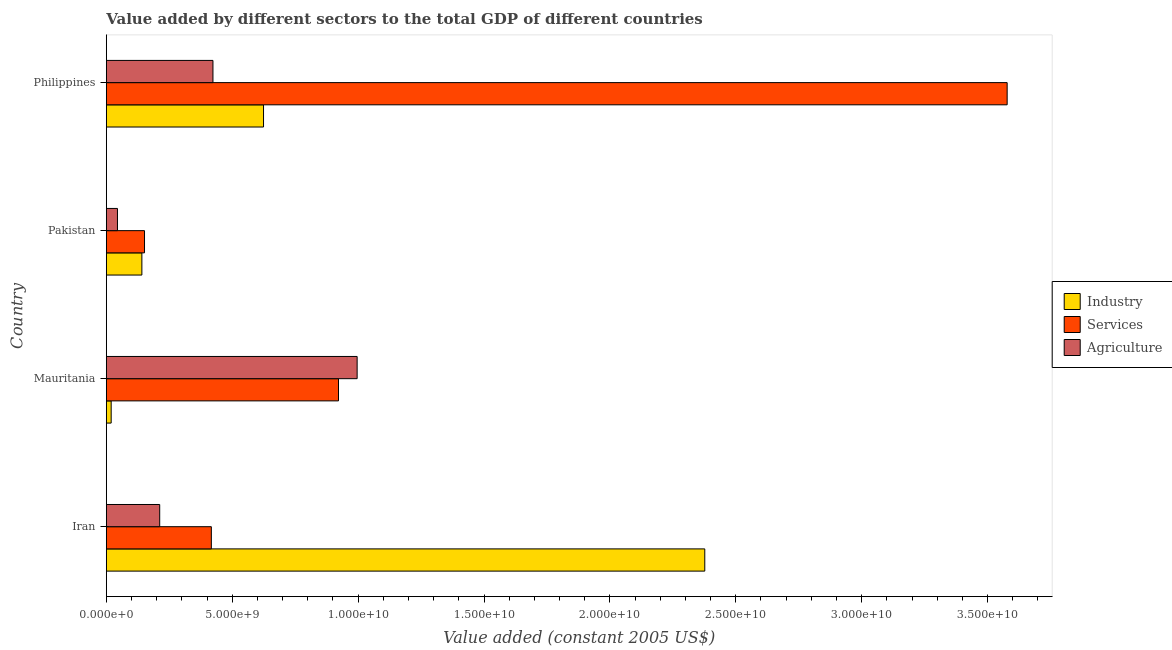How many bars are there on the 1st tick from the top?
Your answer should be compact. 3. How many bars are there on the 4th tick from the bottom?
Your response must be concise. 3. What is the value added by industrial sector in Pakistan?
Provide a short and direct response. 1.41e+09. Across all countries, what is the maximum value added by agricultural sector?
Offer a very short reply. 9.96e+09. Across all countries, what is the minimum value added by industrial sector?
Ensure brevity in your answer.  1.92e+08. In which country was the value added by agricultural sector maximum?
Offer a terse response. Mauritania. In which country was the value added by industrial sector minimum?
Offer a terse response. Mauritania. What is the total value added by services in the graph?
Offer a terse response. 5.07e+1. What is the difference between the value added by industrial sector in Mauritania and that in Pakistan?
Offer a very short reply. -1.22e+09. What is the difference between the value added by industrial sector in Philippines and the value added by agricultural sector in Pakistan?
Give a very brief answer. 5.80e+09. What is the average value added by services per country?
Offer a terse response. 1.27e+1. What is the difference between the value added by services and value added by agricultural sector in Philippines?
Your answer should be compact. 3.15e+1. In how many countries, is the value added by services greater than 25000000000 US$?
Your answer should be very brief. 1. What is the ratio of the value added by services in Pakistan to that in Philippines?
Your answer should be very brief. 0.04. Is the value added by agricultural sector in Mauritania less than that in Philippines?
Give a very brief answer. No. What is the difference between the highest and the second highest value added by agricultural sector?
Offer a terse response. 5.73e+09. What is the difference between the highest and the lowest value added by agricultural sector?
Make the answer very short. 9.52e+09. In how many countries, is the value added by services greater than the average value added by services taken over all countries?
Give a very brief answer. 1. What does the 1st bar from the top in Philippines represents?
Provide a succinct answer. Agriculture. What does the 2nd bar from the bottom in Mauritania represents?
Give a very brief answer. Services. Is it the case that in every country, the sum of the value added by industrial sector and value added by services is greater than the value added by agricultural sector?
Provide a succinct answer. No. How many bars are there?
Keep it short and to the point. 12. Are all the bars in the graph horizontal?
Keep it short and to the point. Yes. What is the difference between two consecutive major ticks on the X-axis?
Your answer should be compact. 5.00e+09. Where does the legend appear in the graph?
Make the answer very short. Center right. What is the title of the graph?
Give a very brief answer. Value added by different sectors to the total GDP of different countries. Does "Transport" appear as one of the legend labels in the graph?
Give a very brief answer. No. What is the label or title of the X-axis?
Make the answer very short. Value added (constant 2005 US$). What is the label or title of the Y-axis?
Offer a very short reply. Country. What is the Value added (constant 2005 US$) of Industry in Iran?
Provide a succinct answer. 2.38e+1. What is the Value added (constant 2005 US$) of Services in Iran?
Ensure brevity in your answer.  4.17e+09. What is the Value added (constant 2005 US$) in Agriculture in Iran?
Your answer should be compact. 2.12e+09. What is the Value added (constant 2005 US$) in Industry in Mauritania?
Offer a terse response. 1.92e+08. What is the Value added (constant 2005 US$) in Services in Mauritania?
Make the answer very short. 9.22e+09. What is the Value added (constant 2005 US$) in Agriculture in Mauritania?
Provide a succinct answer. 9.96e+09. What is the Value added (constant 2005 US$) of Industry in Pakistan?
Keep it short and to the point. 1.41e+09. What is the Value added (constant 2005 US$) of Services in Pakistan?
Offer a very short reply. 1.52e+09. What is the Value added (constant 2005 US$) in Agriculture in Pakistan?
Your answer should be compact. 4.42e+08. What is the Value added (constant 2005 US$) in Industry in Philippines?
Provide a short and direct response. 6.24e+09. What is the Value added (constant 2005 US$) of Services in Philippines?
Keep it short and to the point. 3.58e+1. What is the Value added (constant 2005 US$) of Agriculture in Philippines?
Keep it short and to the point. 4.23e+09. Across all countries, what is the maximum Value added (constant 2005 US$) in Industry?
Provide a succinct answer. 2.38e+1. Across all countries, what is the maximum Value added (constant 2005 US$) in Services?
Give a very brief answer. 3.58e+1. Across all countries, what is the maximum Value added (constant 2005 US$) in Agriculture?
Make the answer very short. 9.96e+09. Across all countries, what is the minimum Value added (constant 2005 US$) of Industry?
Your answer should be very brief. 1.92e+08. Across all countries, what is the minimum Value added (constant 2005 US$) in Services?
Offer a very short reply. 1.52e+09. Across all countries, what is the minimum Value added (constant 2005 US$) of Agriculture?
Provide a succinct answer. 4.42e+08. What is the total Value added (constant 2005 US$) of Industry in the graph?
Keep it short and to the point. 3.16e+1. What is the total Value added (constant 2005 US$) in Services in the graph?
Offer a terse response. 5.07e+1. What is the total Value added (constant 2005 US$) in Agriculture in the graph?
Ensure brevity in your answer.  1.68e+1. What is the difference between the Value added (constant 2005 US$) of Industry in Iran and that in Mauritania?
Provide a succinct answer. 2.36e+1. What is the difference between the Value added (constant 2005 US$) in Services in Iran and that in Mauritania?
Your answer should be very brief. -5.05e+09. What is the difference between the Value added (constant 2005 US$) of Agriculture in Iran and that in Mauritania?
Keep it short and to the point. -7.84e+09. What is the difference between the Value added (constant 2005 US$) in Industry in Iran and that in Pakistan?
Make the answer very short. 2.24e+1. What is the difference between the Value added (constant 2005 US$) in Services in Iran and that in Pakistan?
Offer a very short reply. 2.65e+09. What is the difference between the Value added (constant 2005 US$) of Agriculture in Iran and that in Pakistan?
Ensure brevity in your answer.  1.68e+09. What is the difference between the Value added (constant 2005 US$) of Industry in Iran and that in Philippines?
Provide a short and direct response. 1.75e+1. What is the difference between the Value added (constant 2005 US$) in Services in Iran and that in Philippines?
Offer a terse response. -3.16e+1. What is the difference between the Value added (constant 2005 US$) of Agriculture in Iran and that in Philippines?
Ensure brevity in your answer.  -2.11e+09. What is the difference between the Value added (constant 2005 US$) in Industry in Mauritania and that in Pakistan?
Offer a terse response. -1.22e+09. What is the difference between the Value added (constant 2005 US$) of Services in Mauritania and that in Pakistan?
Keep it short and to the point. 7.70e+09. What is the difference between the Value added (constant 2005 US$) in Agriculture in Mauritania and that in Pakistan?
Provide a succinct answer. 9.52e+09. What is the difference between the Value added (constant 2005 US$) in Industry in Mauritania and that in Philippines?
Offer a very short reply. -6.05e+09. What is the difference between the Value added (constant 2005 US$) in Services in Mauritania and that in Philippines?
Make the answer very short. -2.66e+1. What is the difference between the Value added (constant 2005 US$) of Agriculture in Mauritania and that in Philippines?
Give a very brief answer. 5.73e+09. What is the difference between the Value added (constant 2005 US$) of Industry in Pakistan and that in Philippines?
Give a very brief answer. -4.83e+09. What is the difference between the Value added (constant 2005 US$) of Services in Pakistan and that in Philippines?
Your response must be concise. -3.43e+1. What is the difference between the Value added (constant 2005 US$) in Agriculture in Pakistan and that in Philippines?
Your answer should be compact. -3.79e+09. What is the difference between the Value added (constant 2005 US$) of Industry in Iran and the Value added (constant 2005 US$) of Services in Mauritania?
Give a very brief answer. 1.45e+1. What is the difference between the Value added (constant 2005 US$) in Industry in Iran and the Value added (constant 2005 US$) in Agriculture in Mauritania?
Ensure brevity in your answer.  1.38e+1. What is the difference between the Value added (constant 2005 US$) of Services in Iran and the Value added (constant 2005 US$) of Agriculture in Mauritania?
Your answer should be very brief. -5.79e+09. What is the difference between the Value added (constant 2005 US$) in Industry in Iran and the Value added (constant 2005 US$) in Services in Pakistan?
Your answer should be very brief. 2.23e+1. What is the difference between the Value added (constant 2005 US$) in Industry in Iran and the Value added (constant 2005 US$) in Agriculture in Pakistan?
Ensure brevity in your answer.  2.33e+1. What is the difference between the Value added (constant 2005 US$) in Services in Iran and the Value added (constant 2005 US$) in Agriculture in Pakistan?
Give a very brief answer. 3.73e+09. What is the difference between the Value added (constant 2005 US$) of Industry in Iran and the Value added (constant 2005 US$) of Services in Philippines?
Keep it short and to the point. -1.20e+1. What is the difference between the Value added (constant 2005 US$) of Industry in Iran and the Value added (constant 2005 US$) of Agriculture in Philippines?
Give a very brief answer. 1.95e+1. What is the difference between the Value added (constant 2005 US$) in Services in Iran and the Value added (constant 2005 US$) in Agriculture in Philippines?
Offer a terse response. -6.35e+07. What is the difference between the Value added (constant 2005 US$) in Industry in Mauritania and the Value added (constant 2005 US$) in Services in Pakistan?
Offer a terse response. -1.32e+09. What is the difference between the Value added (constant 2005 US$) of Industry in Mauritania and the Value added (constant 2005 US$) of Agriculture in Pakistan?
Your answer should be very brief. -2.50e+08. What is the difference between the Value added (constant 2005 US$) in Services in Mauritania and the Value added (constant 2005 US$) in Agriculture in Pakistan?
Your answer should be very brief. 8.78e+09. What is the difference between the Value added (constant 2005 US$) in Industry in Mauritania and the Value added (constant 2005 US$) in Services in Philippines?
Provide a succinct answer. -3.56e+1. What is the difference between the Value added (constant 2005 US$) in Industry in Mauritania and the Value added (constant 2005 US$) in Agriculture in Philippines?
Give a very brief answer. -4.04e+09. What is the difference between the Value added (constant 2005 US$) of Services in Mauritania and the Value added (constant 2005 US$) of Agriculture in Philippines?
Give a very brief answer. 4.99e+09. What is the difference between the Value added (constant 2005 US$) in Industry in Pakistan and the Value added (constant 2005 US$) in Services in Philippines?
Offer a very short reply. -3.44e+1. What is the difference between the Value added (constant 2005 US$) in Industry in Pakistan and the Value added (constant 2005 US$) in Agriculture in Philippines?
Provide a short and direct response. -2.82e+09. What is the difference between the Value added (constant 2005 US$) of Services in Pakistan and the Value added (constant 2005 US$) of Agriculture in Philippines?
Provide a succinct answer. -2.72e+09. What is the average Value added (constant 2005 US$) in Industry per country?
Keep it short and to the point. 7.90e+09. What is the average Value added (constant 2005 US$) in Services per country?
Make the answer very short. 1.27e+1. What is the average Value added (constant 2005 US$) in Agriculture per country?
Your answer should be very brief. 4.19e+09. What is the difference between the Value added (constant 2005 US$) of Industry and Value added (constant 2005 US$) of Services in Iran?
Keep it short and to the point. 1.96e+1. What is the difference between the Value added (constant 2005 US$) in Industry and Value added (constant 2005 US$) in Agriculture in Iran?
Your response must be concise. 2.16e+1. What is the difference between the Value added (constant 2005 US$) of Services and Value added (constant 2005 US$) of Agriculture in Iran?
Make the answer very short. 2.05e+09. What is the difference between the Value added (constant 2005 US$) of Industry and Value added (constant 2005 US$) of Services in Mauritania?
Make the answer very short. -9.03e+09. What is the difference between the Value added (constant 2005 US$) in Industry and Value added (constant 2005 US$) in Agriculture in Mauritania?
Keep it short and to the point. -9.77e+09. What is the difference between the Value added (constant 2005 US$) of Services and Value added (constant 2005 US$) of Agriculture in Mauritania?
Offer a terse response. -7.40e+08. What is the difference between the Value added (constant 2005 US$) in Industry and Value added (constant 2005 US$) in Services in Pakistan?
Make the answer very short. -1.05e+08. What is the difference between the Value added (constant 2005 US$) in Industry and Value added (constant 2005 US$) in Agriculture in Pakistan?
Your answer should be compact. 9.70e+08. What is the difference between the Value added (constant 2005 US$) in Services and Value added (constant 2005 US$) in Agriculture in Pakistan?
Offer a very short reply. 1.07e+09. What is the difference between the Value added (constant 2005 US$) in Industry and Value added (constant 2005 US$) in Services in Philippines?
Your response must be concise. -2.95e+1. What is the difference between the Value added (constant 2005 US$) of Industry and Value added (constant 2005 US$) of Agriculture in Philippines?
Your response must be concise. 2.01e+09. What is the difference between the Value added (constant 2005 US$) in Services and Value added (constant 2005 US$) in Agriculture in Philippines?
Provide a succinct answer. 3.15e+1. What is the ratio of the Value added (constant 2005 US$) in Industry in Iran to that in Mauritania?
Your answer should be compact. 123.7. What is the ratio of the Value added (constant 2005 US$) of Services in Iran to that in Mauritania?
Offer a very short reply. 0.45. What is the ratio of the Value added (constant 2005 US$) of Agriculture in Iran to that in Mauritania?
Offer a very short reply. 0.21. What is the ratio of the Value added (constant 2005 US$) of Industry in Iran to that in Pakistan?
Ensure brevity in your answer.  16.84. What is the ratio of the Value added (constant 2005 US$) of Services in Iran to that in Pakistan?
Offer a very short reply. 2.75. What is the ratio of the Value added (constant 2005 US$) in Agriculture in Iran to that in Pakistan?
Your response must be concise. 4.79. What is the ratio of the Value added (constant 2005 US$) in Industry in Iran to that in Philippines?
Your answer should be compact. 3.81. What is the ratio of the Value added (constant 2005 US$) of Services in Iran to that in Philippines?
Make the answer very short. 0.12. What is the ratio of the Value added (constant 2005 US$) of Agriculture in Iran to that in Philippines?
Provide a succinct answer. 0.5. What is the ratio of the Value added (constant 2005 US$) in Industry in Mauritania to that in Pakistan?
Offer a very short reply. 0.14. What is the ratio of the Value added (constant 2005 US$) in Services in Mauritania to that in Pakistan?
Ensure brevity in your answer.  6.08. What is the ratio of the Value added (constant 2005 US$) of Agriculture in Mauritania to that in Pakistan?
Keep it short and to the point. 22.52. What is the ratio of the Value added (constant 2005 US$) of Industry in Mauritania to that in Philippines?
Provide a short and direct response. 0.03. What is the ratio of the Value added (constant 2005 US$) of Services in Mauritania to that in Philippines?
Ensure brevity in your answer.  0.26. What is the ratio of the Value added (constant 2005 US$) of Agriculture in Mauritania to that in Philippines?
Ensure brevity in your answer.  2.35. What is the ratio of the Value added (constant 2005 US$) in Industry in Pakistan to that in Philippines?
Offer a very short reply. 0.23. What is the ratio of the Value added (constant 2005 US$) in Services in Pakistan to that in Philippines?
Ensure brevity in your answer.  0.04. What is the ratio of the Value added (constant 2005 US$) in Agriculture in Pakistan to that in Philippines?
Your answer should be very brief. 0.1. What is the difference between the highest and the second highest Value added (constant 2005 US$) of Industry?
Offer a terse response. 1.75e+1. What is the difference between the highest and the second highest Value added (constant 2005 US$) in Services?
Your response must be concise. 2.66e+1. What is the difference between the highest and the second highest Value added (constant 2005 US$) of Agriculture?
Your answer should be compact. 5.73e+09. What is the difference between the highest and the lowest Value added (constant 2005 US$) in Industry?
Your answer should be very brief. 2.36e+1. What is the difference between the highest and the lowest Value added (constant 2005 US$) in Services?
Your answer should be compact. 3.43e+1. What is the difference between the highest and the lowest Value added (constant 2005 US$) in Agriculture?
Keep it short and to the point. 9.52e+09. 